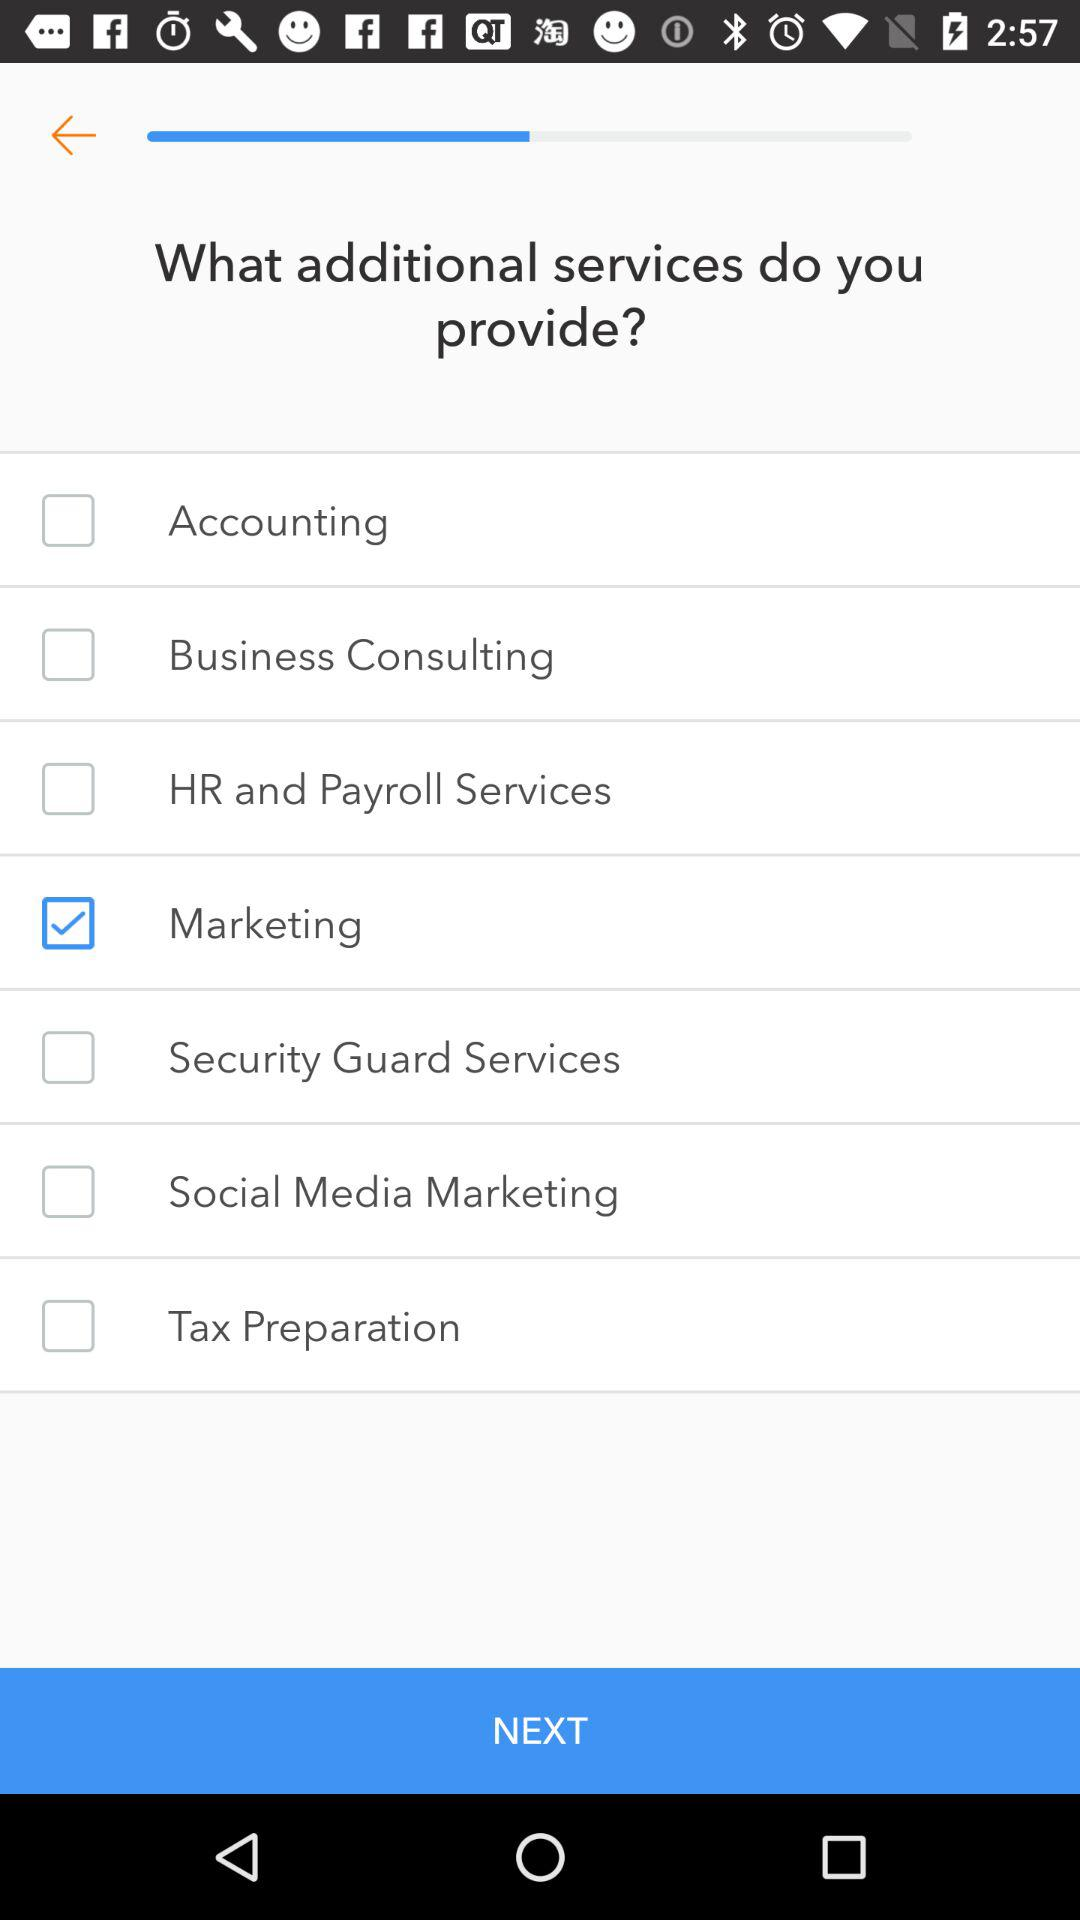How many of the services offered are related to marketing?
Answer the question using a single word or phrase. 2 